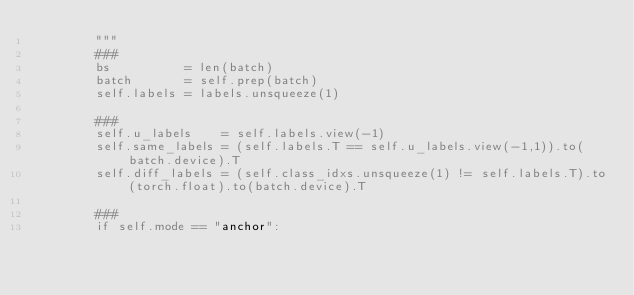Convert code to text. <code><loc_0><loc_0><loc_500><loc_500><_Python_>        """
        ###
        bs          = len(batch)
        batch       = self.prep(batch)
        self.labels = labels.unsqueeze(1)

        ###
        self.u_labels    = self.labels.view(-1)
        self.same_labels = (self.labels.T == self.u_labels.view(-1,1)).to(batch.device).T
        self.diff_labels = (self.class_idxs.unsqueeze(1) != self.labels.T).to(torch.float).to(batch.device).T

        ###
        if self.mode == "anchor":</code> 